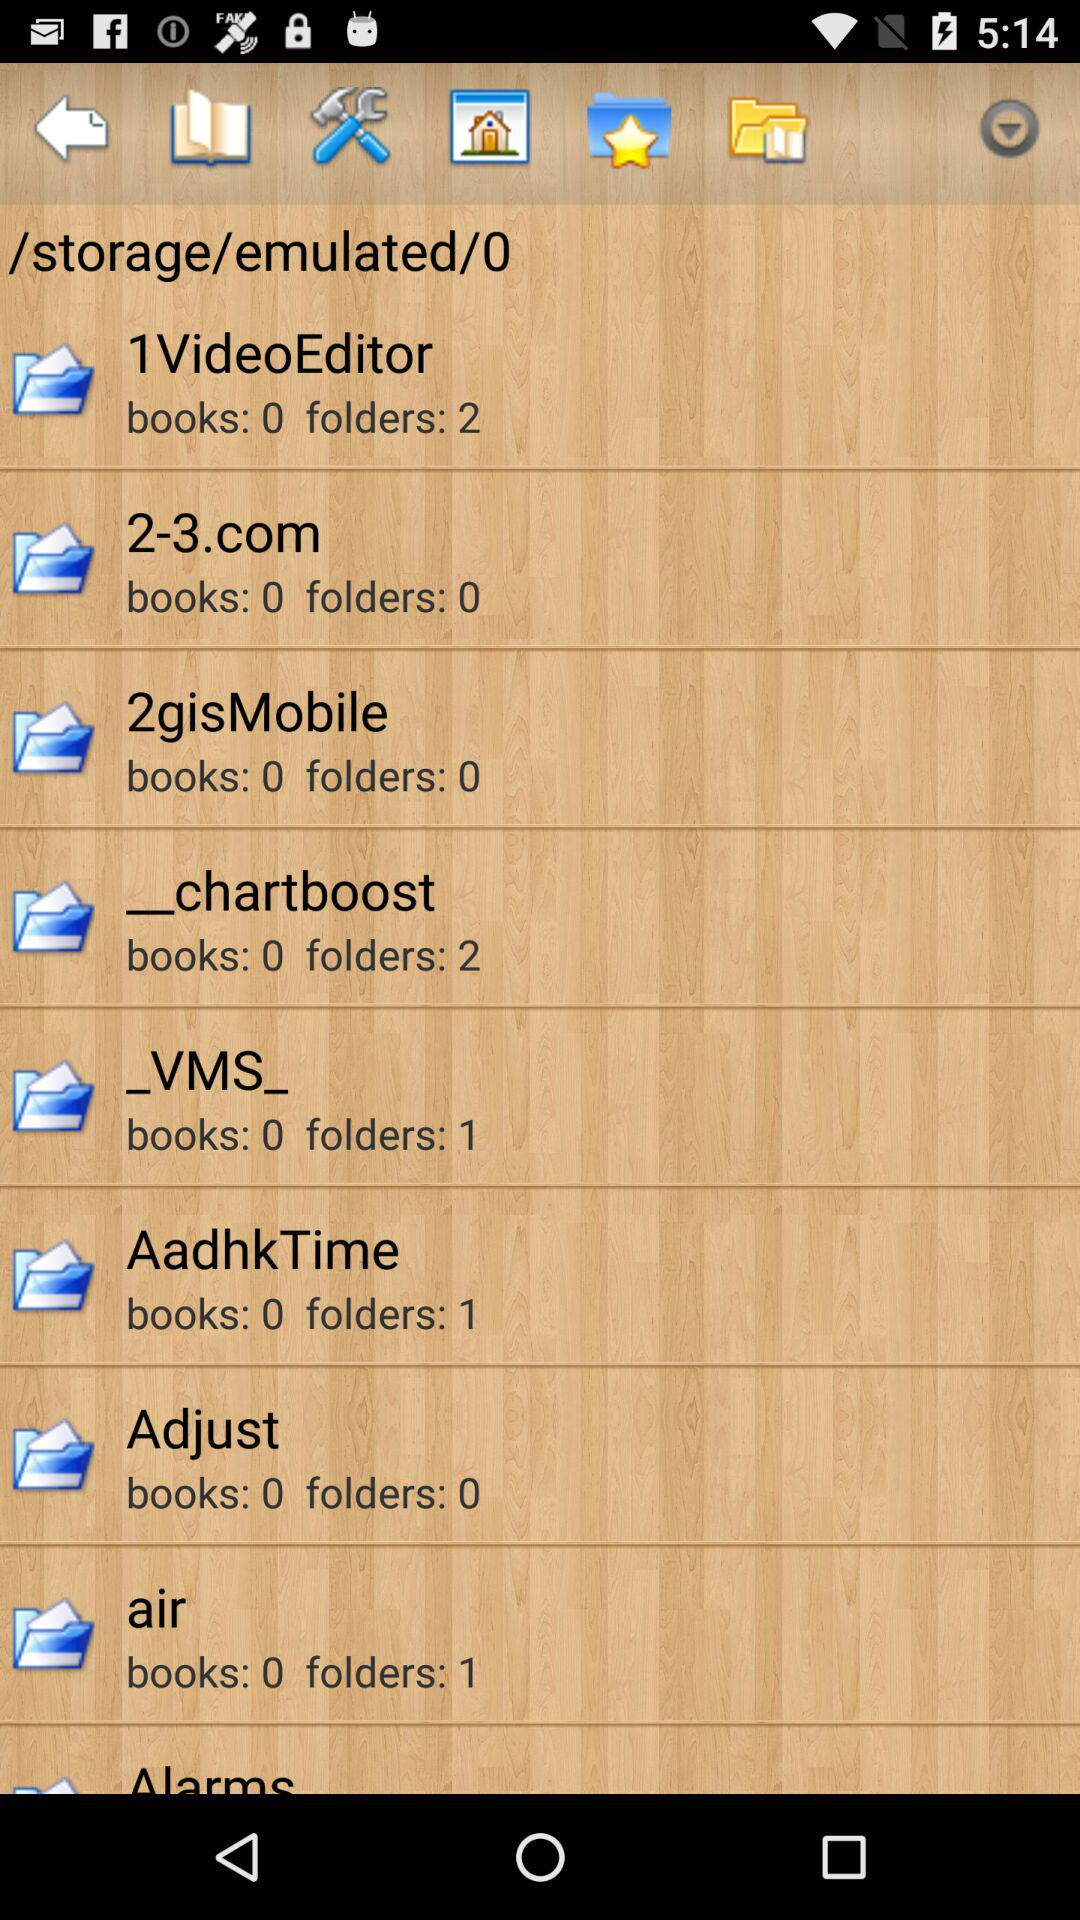How many books does "Adjust" have? "Adjust" has 0 books. 